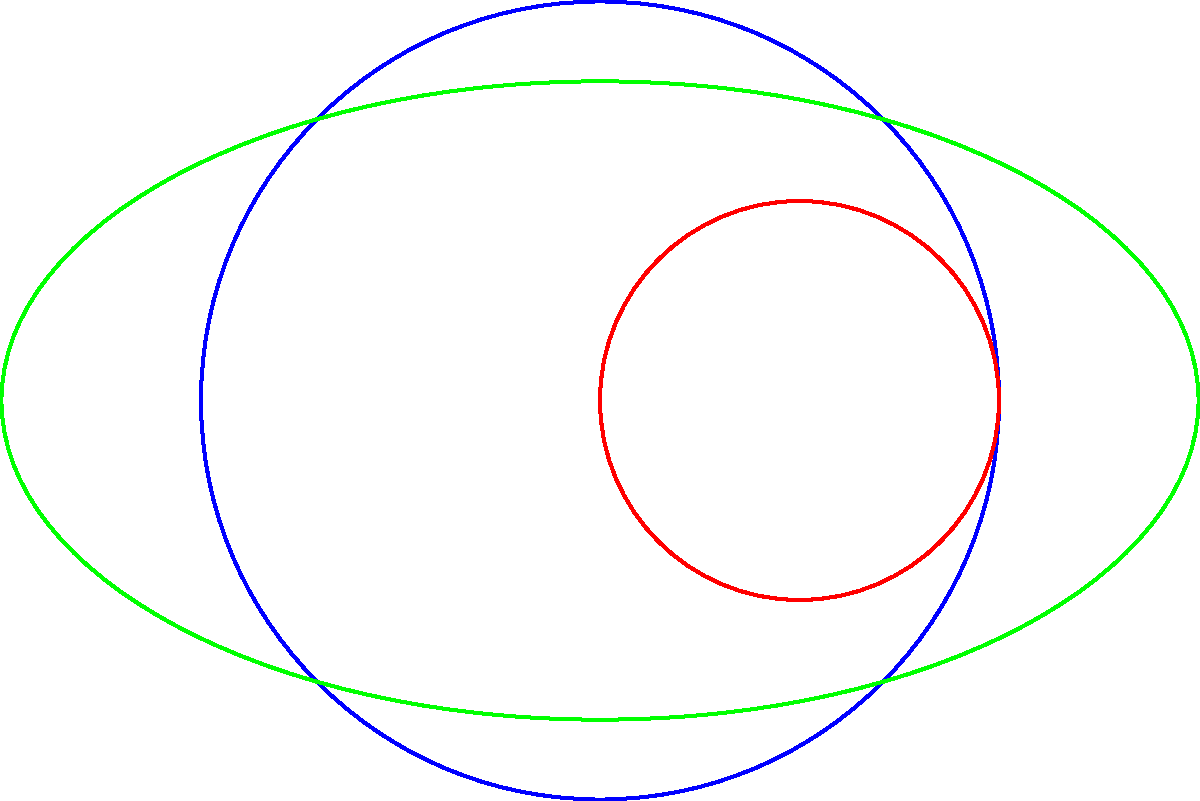In the diagram above, three simple closed curves (C1, C2, and C3) are shown. Consider the Jordan curve theorem, which states that every simple closed curve divides the plane into two regions: an interior and an exterior. How many distinct regions are created by these three curves, and what is the significance of points A and B in relation to these regions? To solve this problem, let's approach it step-by-step:

1. First, recall the Jordan curve theorem: every simple closed curve divides the plane into two regions (interior and exterior).

2. Let's count the regions created by each curve:
   - C1 (blue circle) divides the plane into 2 regions
   - C2 (red circle) further divides one of C1's regions, adding 1 more (total: 3)
   - C3 (green ellipse) intersects both C1 and C2, potentially creating more regions

3. To count the total regions, we need to identify all areas bounded by different combinations of the curves:
   - Region inside C2 only
   - Region inside C1 and C3, but outside C2
   - Region inside all three curves
   - Region inside C1, but outside C2 and C3
   - Region inside C3, but outside C1 and C2
   - Region outside all three curves

4. Counting these regions, we find that there are 6 distinct regions created by the three curves.

5. Now, let's consider points A and B:
   - Point A is at the center of C1 and is inside all three curves
   - Point B is at the center of C2 and is inside C1 and C2, but outside C3

6. The significance of these points is that they demonstrate how the curves divide the plane:
   - A is in the innermost region (inside all curves)
   - B is in a region that's inside two curves but outside one

This example illustrates how multiple simple closed curves can create a complex division of the plane, extending the concept of the Jordan curve theorem to multiple intersecting curves.
Answer: 6 regions; A and B are in different regions, demonstrating the plane division. 